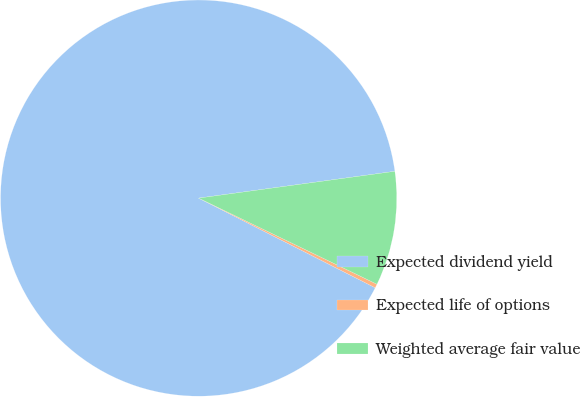Convert chart. <chart><loc_0><loc_0><loc_500><loc_500><pie_chart><fcel>Expected dividend yield<fcel>Expected life of options<fcel>Weighted average fair value<nl><fcel>90.36%<fcel>0.32%<fcel>9.32%<nl></chart> 